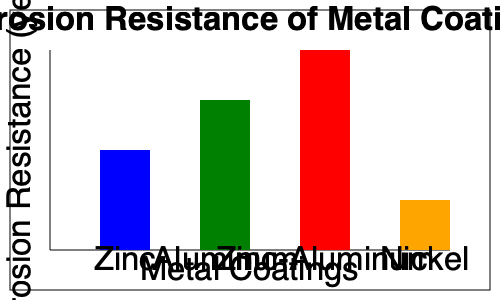Based on the graph showing corrosion resistance of various metal coatings for automotive body panels, which coating would you recommend for a vehicle that needs to withstand harsh environmental conditions for at least 15 years without significant corrosion? Explain your reasoning, considering both corrosion resistance and cost-effectiveness. To answer this question, we need to analyze the graph and consider both the corrosion resistance and cost-effectiveness of each coating:

1. Zinc coating:
   - Corrosion resistance: Approximately 10 years
   - Generally less expensive than other options

2. Aluminum coating:
   - Corrosion resistance: Approximately 15 years
   - More expensive than zinc, but still relatively cost-effective

3. Zinc-Aluminum coating:
   - Corrosion resistance: Approximately 20 years
   - More expensive than zinc or aluminum alone

4. Nickel coating:
   - Corrosion resistance: Approximately 5 years
   - Generally more expensive than zinc or aluminum

Given the requirement of at least 15 years of corrosion resistance:
- Zinc and Nickel coatings can be eliminated as they do not meet the minimum requirement.
- Aluminum coating meets the minimum requirement.
- Zinc-Aluminum coating exceeds the minimum requirement.

Considering cost-effectiveness:
- Aluminum coating is likely more cost-effective than Zinc-Aluminum, as it meets the minimum requirement without excessive overengineering.
- Zinc-Aluminum coating may be justified if the additional 5 years of protection are deemed necessary for the specific application.

Therefore, the most suitable recommendation would be the Aluminum coating, as it meets the minimum corrosion resistance requirement of 15 years while likely being more cost-effective than the Zinc-Aluminum option.
Answer: Aluminum coating 